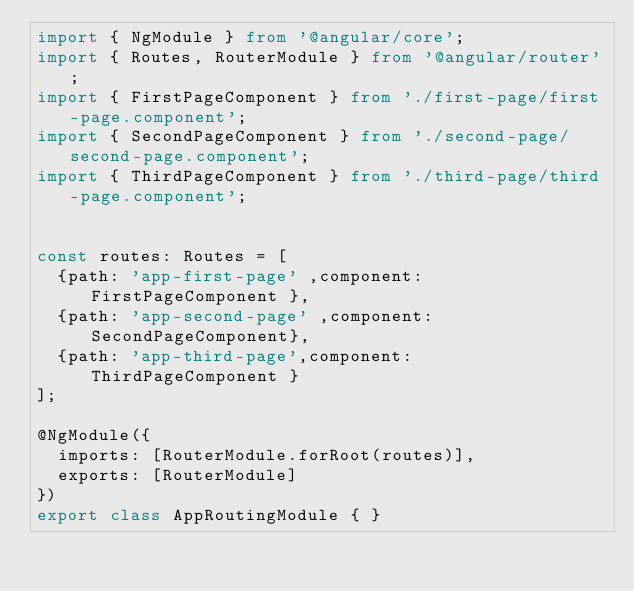<code> <loc_0><loc_0><loc_500><loc_500><_TypeScript_>import { NgModule } from '@angular/core';
import { Routes, RouterModule } from '@angular/router';
import { FirstPageComponent } from './first-page/first-page.component';
import { SecondPageComponent } from './second-page/second-page.component';
import { ThirdPageComponent } from './third-page/third-page.component';


const routes: Routes = [  
  {path: 'app-first-page' ,component: FirstPageComponent },
  {path: 'app-second-page' ,component:  SecondPageComponent},
  {path: 'app-third-page',component: ThirdPageComponent }
];

@NgModule({
  imports: [RouterModule.forRoot(routes)],
  exports: [RouterModule]
})
export class AppRoutingModule { }
</code> 